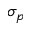<formula> <loc_0><loc_0><loc_500><loc_500>\sigma _ { p }</formula> 